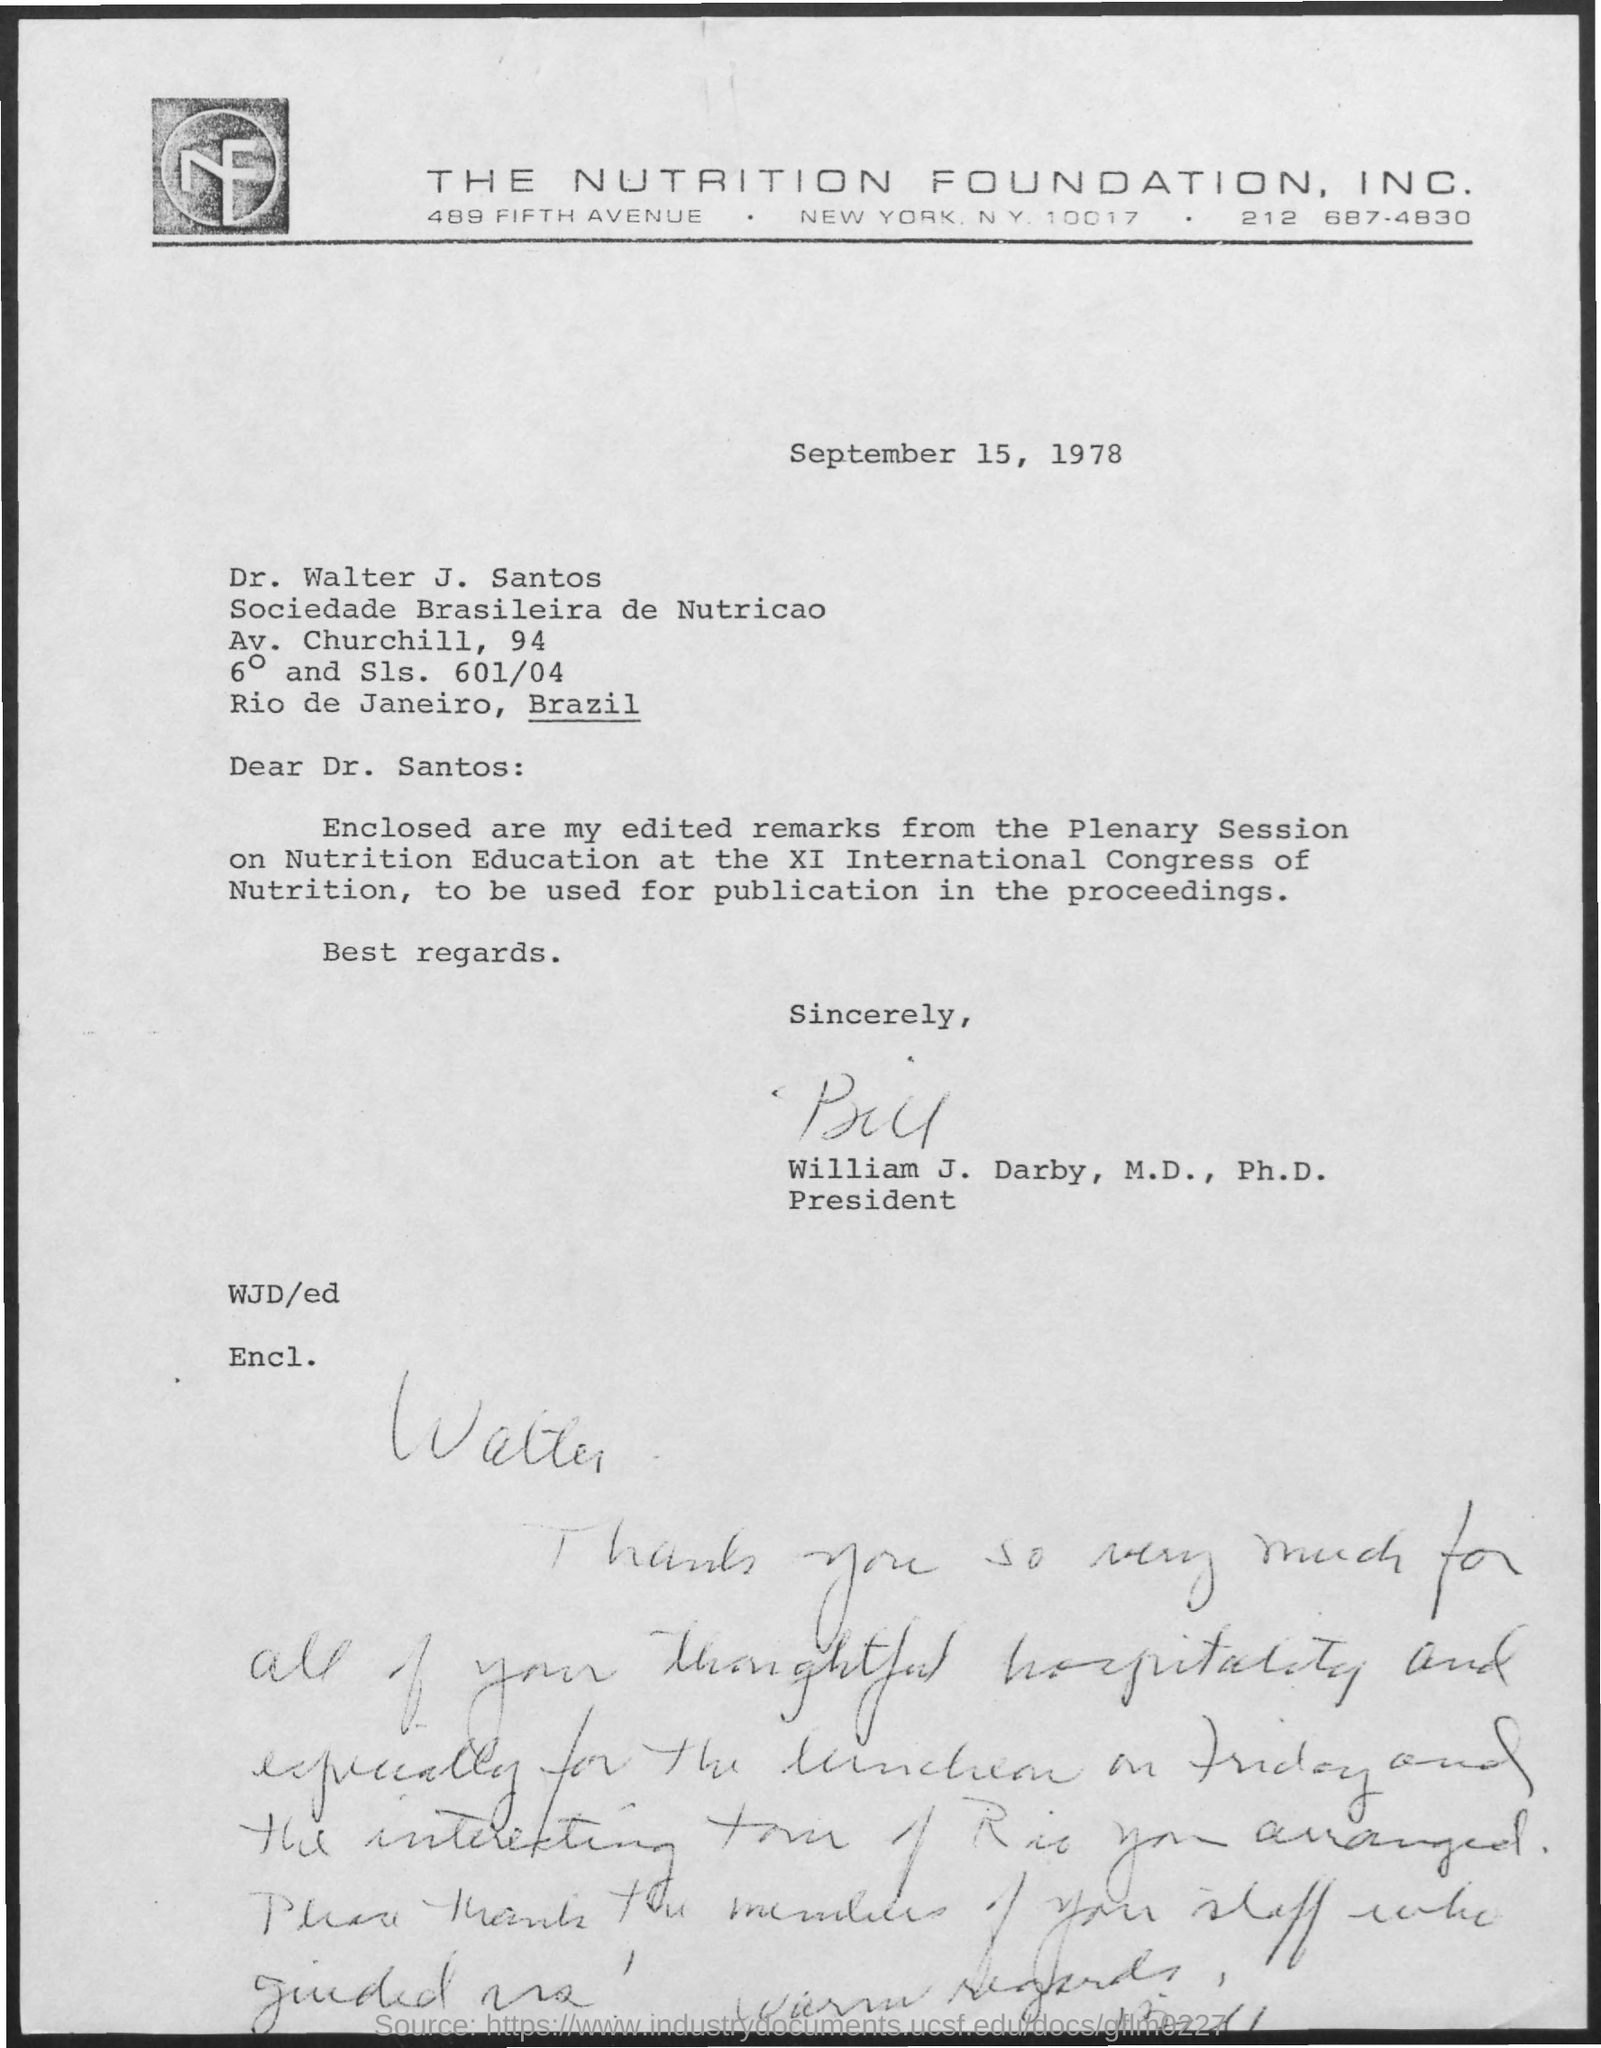Find the date of the letter?
Your answer should be compact. September 15, 1978. Who signed the document?
Your answer should be compact. William J. Darby. 